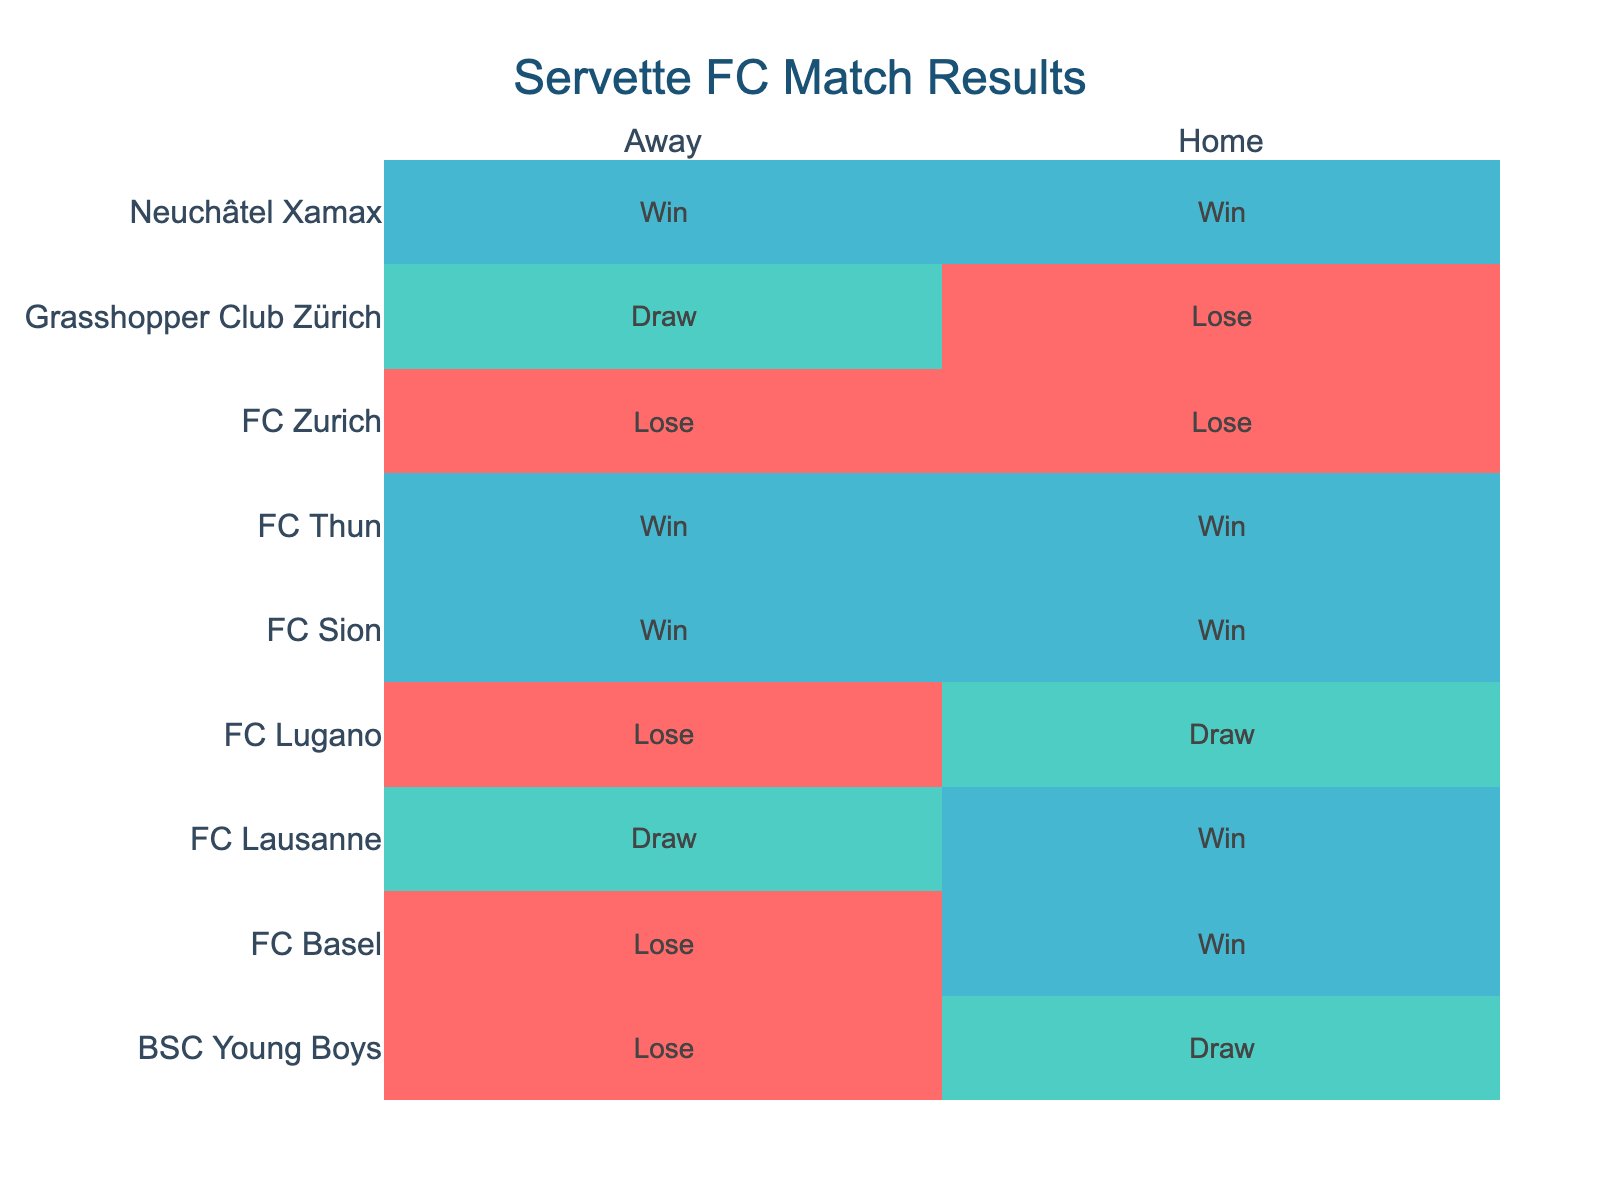What were the results against FC Basel at home? The table shows that Servette FC won its home match against FC Basel. Hence, the result is "Win".
Answer: Win How many matches did Servette FC play away against BSC Young Boys? There is one entry for BSC Young Boys in the away category, which indicates that Servette FC played one match away against them.
Answer: 1 Did Servette FC win against FC Zurich both at home and away? The table shows that Servette FC lost at home and also lost away against FC Zurich. Therefore, they did not win.
Answer: No How many total wins did Servette FC achieve at home? By counting the entries in the table where the home result is "Win", we find that there are four wins at home (against FC Sion, FC Lausanne, Neuchâtel Xamax, and FC Thun).
Answer: 4 Which opponent did Servette FC achieve the maximum number of wins against? Looking at the wins recorded, Servette FC achieved two wins against FC Sion and Neuchâtel Xamax while playing at home and away. No other team has more than two wins listed, making both FC Sion and Neuchâtel Xamax the teams with maximum wins.
Answer: FC Sion and Neuchâtel Xamax What was the overall win-loss ratio for Servette FC when playing against FC Lugano? Servette FC had one draw and one loss against FC Lugano, with no wins. The win-loss ratio is therefore 0 wins to 1 loss.
Answer: 0:1 How many times did Servette FC draw in home matches? From the table, Servette had two draws at home (against BSC Young Boys and FC Lugano). Therefore, the total number of draws in home matches is two.
Answer: 2 Is it true that Servette FC lost more away matches than they won? A quick look at the table reveals that they won 3 matches and lost 4 matches while playing away. Therefore, it is indeed true that they lost more.
Answer: Yes Can you find an opponent against which Servette FC won all their matches? The matches against FC Sion and Neuchâtel Xamax show wins for both home and away games, meaning Servette FC won against both teams in every match they played this season.
Answer: FC Sion and Neuchâtel Xamax 